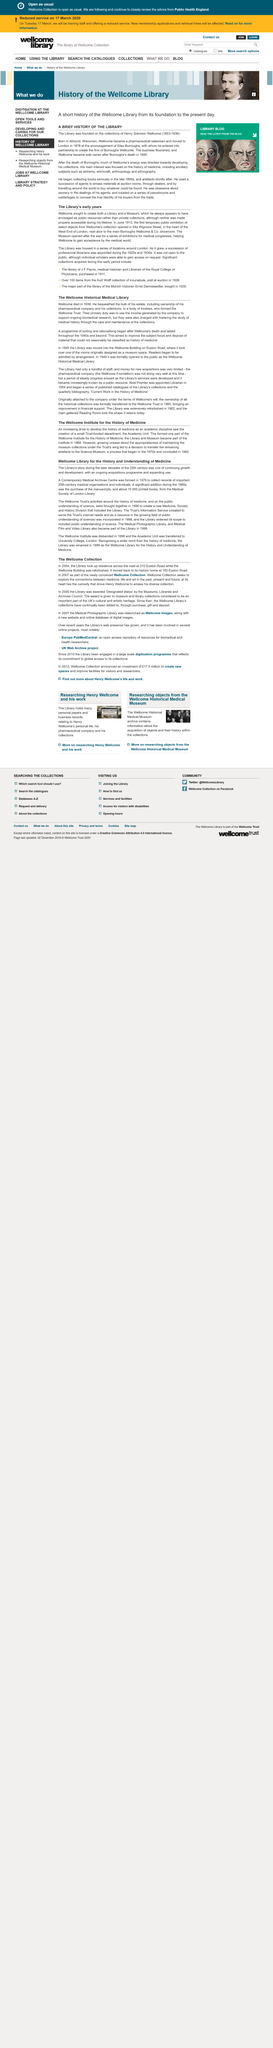Mention a couple of crucial points in this snapshot. Wellcome aimed to establish a Library and a Museum. The Wellcome Trust was established by the body of trustees who formed it. In 2004, the British Library moved its operations to 210 Euston Road, where it currently resides. The first temporary public exhibition opened in June 1913. During the later decades of the 20th century, the Library's story was one of continuous growth and development through an ongoing acquisitions program and an increasingly widespread use of its resources. 